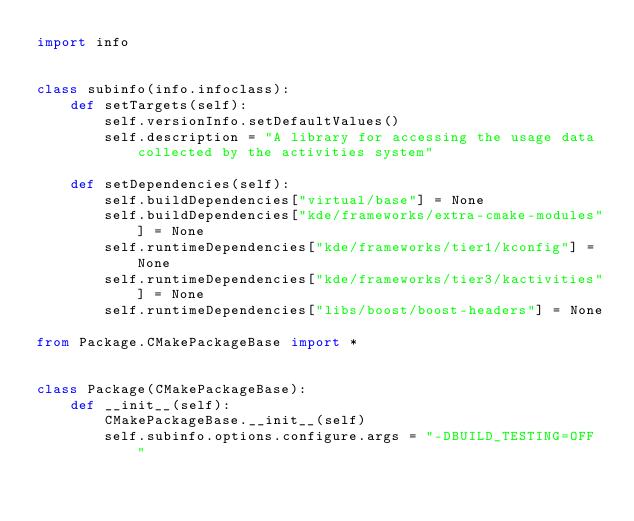Convert code to text. <code><loc_0><loc_0><loc_500><loc_500><_Python_>import info


class subinfo(info.infoclass):
    def setTargets(self):
        self.versionInfo.setDefaultValues()
        self.description = "A library for accessing the usage data collected by the activities system"

    def setDependencies(self):
        self.buildDependencies["virtual/base"] = None
        self.buildDependencies["kde/frameworks/extra-cmake-modules"] = None
        self.runtimeDependencies["kde/frameworks/tier1/kconfig"] = None
        self.runtimeDependencies["kde/frameworks/tier3/kactivities"] = None
        self.runtimeDependencies["libs/boost/boost-headers"] = None

from Package.CMakePackageBase import *


class Package(CMakePackageBase):
    def __init__(self):
        CMakePackageBase.__init__(self)
        self.subinfo.options.configure.args = "-DBUILD_TESTING=OFF "
</code> 